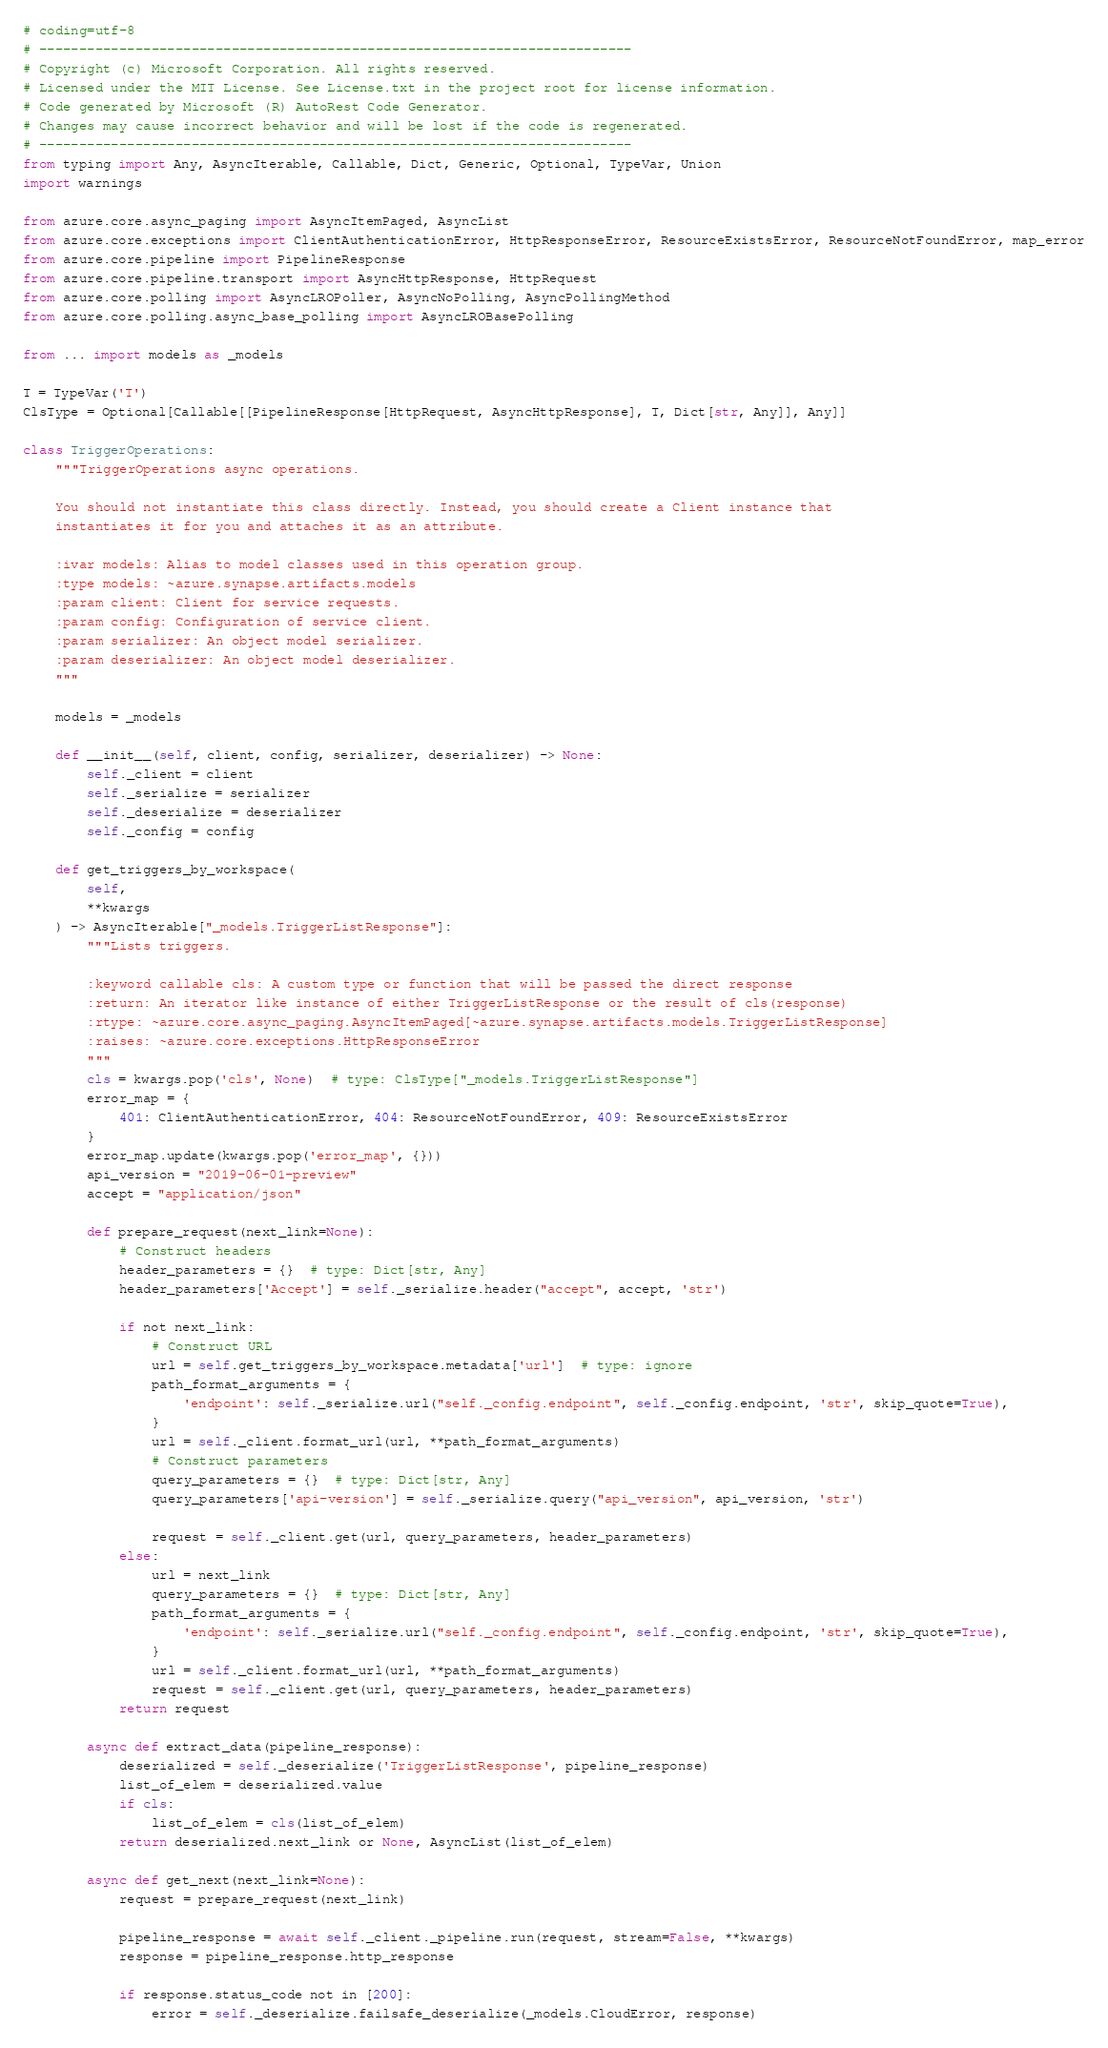<code> <loc_0><loc_0><loc_500><loc_500><_Python_># coding=utf-8
# --------------------------------------------------------------------------
# Copyright (c) Microsoft Corporation. All rights reserved.
# Licensed under the MIT License. See License.txt in the project root for license information.
# Code generated by Microsoft (R) AutoRest Code Generator.
# Changes may cause incorrect behavior and will be lost if the code is regenerated.
# --------------------------------------------------------------------------
from typing import Any, AsyncIterable, Callable, Dict, Generic, Optional, TypeVar, Union
import warnings

from azure.core.async_paging import AsyncItemPaged, AsyncList
from azure.core.exceptions import ClientAuthenticationError, HttpResponseError, ResourceExistsError, ResourceNotFoundError, map_error
from azure.core.pipeline import PipelineResponse
from azure.core.pipeline.transport import AsyncHttpResponse, HttpRequest
from azure.core.polling import AsyncLROPoller, AsyncNoPolling, AsyncPollingMethod
from azure.core.polling.async_base_polling import AsyncLROBasePolling

from ... import models as _models

T = TypeVar('T')
ClsType = Optional[Callable[[PipelineResponse[HttpRequest, AsyncHttpResponse], T, Dict[str, Any]], Any]]

class TriggerOperations:
    """TriggerOperations async operations.

    You should not instantiate this class directly. Instead, you should create a Client instance that
    instantiates it for you and attaches it as an attribute.

    :ivar models: Alias to model classes used in this operation group.
    :type models: ~azure.synapse.artifacts.models
    :param client: Client for service requests.
    :param config: Configuration of service client.
    :param serializer: An object model serializer.
    :param deserializer: An object model deserializer.
    """

    models = _models

    def __init__(self, client, config, serializer, deserializer) -> None:
        self._client = client
        self._serialize = serializer
        self._deserialize = deserializer
        self._config = config

    def get_triggers_by_workspace(
        self,
        **kwargs
    ) -> AsyncIterable["_models.TriggerListResponse"]:
        """Lists triggers.

        :keyword callable cls: A custom type or function that will be passed the direct response
        :return: An iterator like instance of either TriggerListResponse or the result of cls(response)
        :rtype: ~azure.core.async_paging.AsyncItemPaged[~azure.synapse.artifacts.models.TriggerListResponse]
        :raises: ~azure.core.exceptions.HttpResponseError
        """
        cls = kwargs.pop('cls', None)  # type: ClsType["_models.TriggerListResponse"]
        error_map = {
            401: ClientAuthenticationError, 404: ResourceNotFoundError, 409: ResourceExistsError
        }
        error_map.update(kwargs.pop('error_map', {}))
        api_version = "2019-06-01-preview"
        accept = "application/json"

        def prepare_request(next_link=None):
            # Construct headers
            header_parameters = {}  # type: Dict[str, Any]
            header_parameters['Accept'] = self._serialize.header("accept", accept, 'str')

            if not next_link:
                # Construct URL
                url = self.get_triggers_by_workspace.metadata['url']  # type: ignore
                path_format_arguments = {
                    'endpoint': self._serialize.url("self._config.endpoint", self._config.endpoint, 'str', skip_quote=True),
                }
                url = self._client.format_url(url, **path_format_arguments)
                # Construct parameters
                query_parameters = {}  # type: Dict[str, Any]
                query_parameters['api-version'] = self._serialize.query("api_version", api_version, 'str')

                request = self._client.get(url, query_parameters, header_parameters)
            else:
                url = next_link
                query_parameters = {}  # type: Dict[str, Any]
                path_format_arguments = {
                    'endpoint': self._serialize.url("self._config.endpoint", self._config.endpoint, 'str', skip_quote=True),
                }
                url = self._client.format_url(url, **path_format_arguments)
                request = self._client.get(url, query_parameters, header_parameters)
            return request

        async def extract_data(pipeline_response):
            deserialized = self._deserialize('TriggerListResponse', pipeline_response)
            list_of_elem = deserialized.value
            if cls:
                list_of_elem = cls(list_of_elem)
            return deserialized.next_link or None, AsyncList(list_of_elem)

        async def get_next(next_link=None):
            request = prepare_request(next_link)

            pipeline_response = await self._client._pipeline.run(request, stream=False, **kwargs)
            response = pipeline_response.http_response

            if response.status_code not in [200]:
                error = self._deserialize.failsafe_deserialize(_models.CloudError, response)</code> 